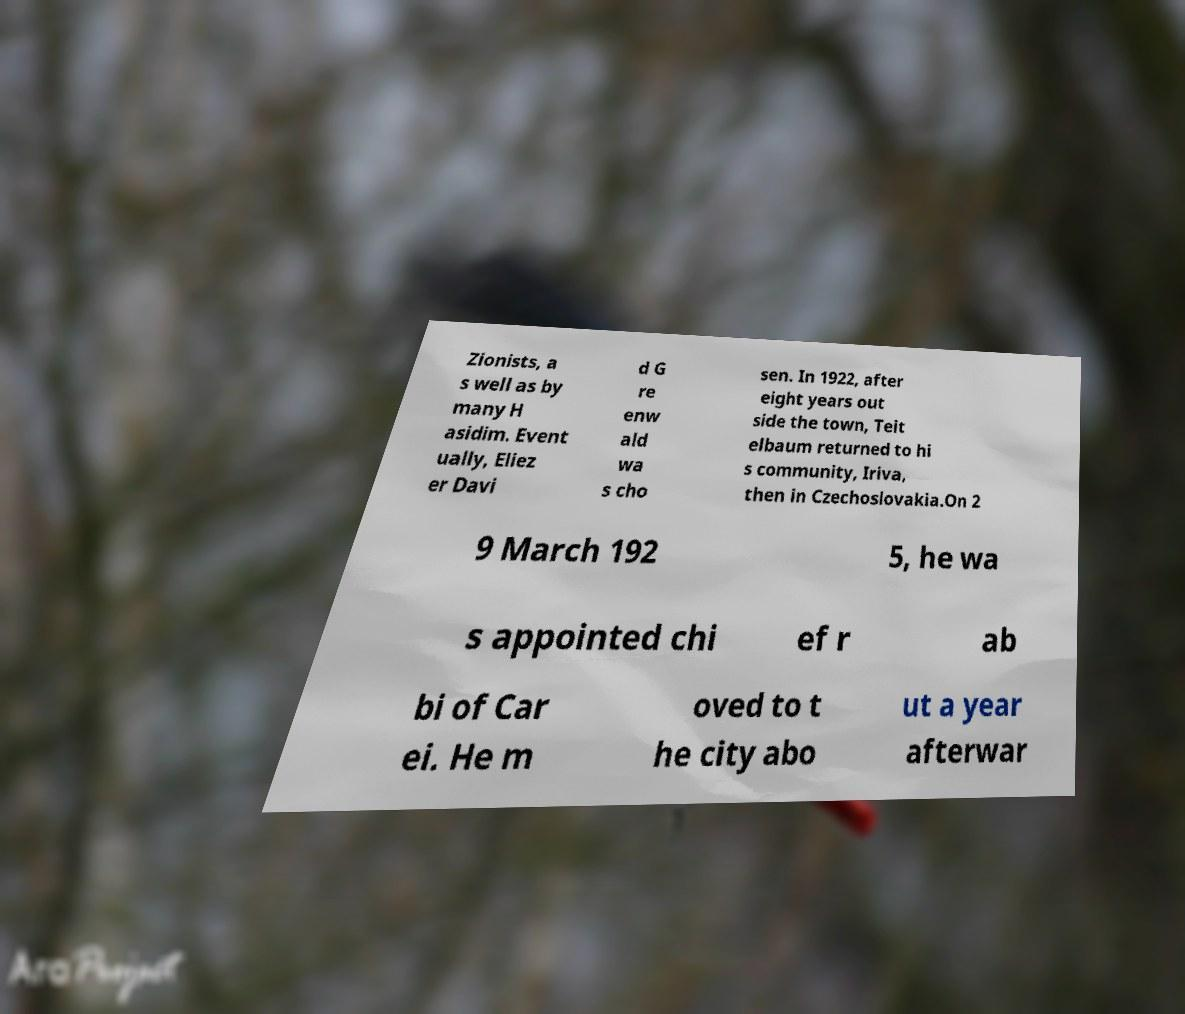Could you extract and type out the text from this image? Zionists, a s well as by many H asidim. Event ually, Eliez er Davi d G re enw ald wa s cho sen. In 1922, after eight years out side the town, Teit elbaum returned to hi s community, Iriva, then in Czechoslovakia.On 2 9 March 192 5, he wa s appointed chi ef r ab bi of Car ei. He m oved to t he city abo ut a year afterwar 